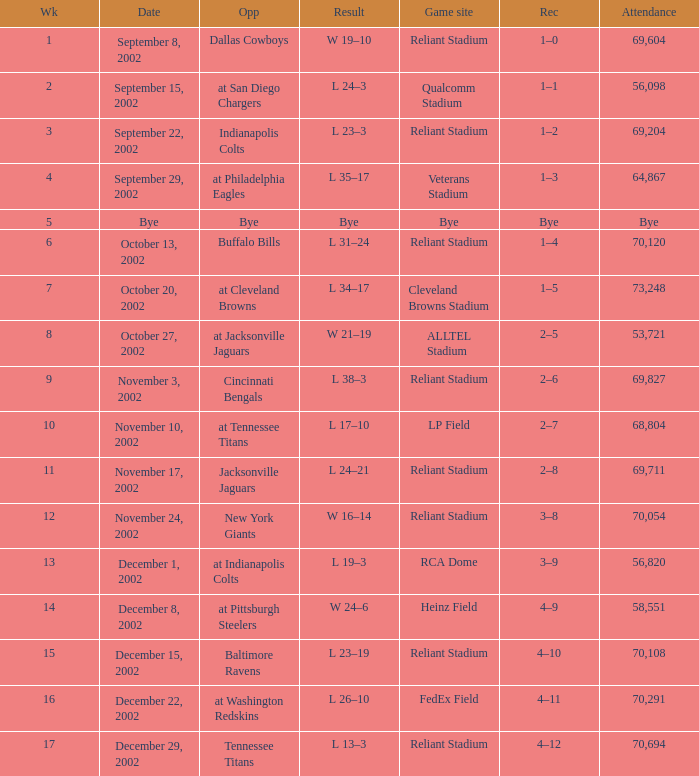Would you be able to parse every entry in this table? {'header': ['Wk', 'Date', 'Opp', 'Result', 'Game site', 'Rec', 'Attendance'], 'rows': [['1', 'September 8, 2002', 'Dallas Cowboys', 'W 19–10', 'Reliant Stadium', '1–0', '69,604'], ['2', 'September 15, 2002', 'at San Diego Chargers', 'L 24–3', 'Qualcomm Stadium', '1–1', '56,098'], ['3', 'September 22, 2002', 'Indianapolis Colts', 'L 23–3', 'Reliant Stadium', '1–2', '69,204'], ['4', 'September 29, 2002', 'at Philadelphia Eagles', 'L 35–17', 'Veterans Stadium', '1–3', '64,867'], ['5', 'Bye', 'Bye', 'Bye', 'Bye', 'Bye', 'Bye'], ['6', 'October 13, 2002', 'Buffalo Bills', 'L 31–24', 'Reliant Stadium', '1–4', '70,120'], ['7', 'October 20, 2002', 'at Cleveland Browns', 'L 34–17', 'Cleveland Browns Stadium', '1–5', '73,248'], ['8', 'October 27, 2002', 'at Jacksonville Jaguars', 'W 21–19', 'ALLTEL Stadium', '2–5', '53,721'], ['9', 'November 3, 2002', 'Cincinnati Bengals', 'L 38–3', 'Reliant Stadium', '2–6', '69,827'], ['10', 'November 10, 2002', 'at Tennessee Titans', 'L 17–10', 'LP Field', '2–7', '68,804'], ['11', 'November 17, 2002', 'Jacksonville Jaguars', 'L 24–21', 'Reliant Stadium', '2–8', '69,711'], ['12', 'November 24, 2002', 'New York Giants', 'W 16–14', 'Reliant Stadium', '3–8', '70,054'], ['13', 'December 1, 2002', 'at Indianapolis Colts', 'L 19–3', 'RCA Dome', '3–9', '56,820'], ['14', 'December 8, 2002', 'at Pittsburgh Steelers', 'W 24–6', 'Heinz Field', '4–9', '58,551'], ['15', 'December 15, 2002', 'Baltimore Ravens', 'L 23–19', 'Reliant Stadium', '4–10', '70,108'], ['16', 'December 22, 2002', 'at Washington Redskins', 'L 26–10', 'FedEx Field', '4–11', '70,291'], ['17', 'December 29, 2002', 'Tennessee Titans', 'L 13–3', 'Reliant Stadium', '4–12', '70,694']]} When did the Texans play at LP Field? November 10, 2002. 